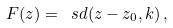<formula> <loc_0><loc_0><loc_500><loc_500>F ( z ) = \ s d ( z - z _ { 0 } , k ) \, ,</formula> 